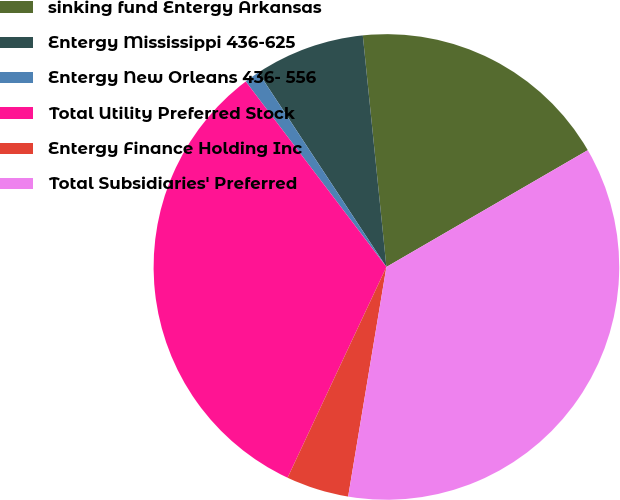Convert chart. <chart><loc_0><loc_0><loc_500><loc_500><pie_chart><fcel>sinking fund Entergy Arkansas<fcel>Entergy Mississippi 436-625<fcel>Entergy New Orleans 436- 556<fcel>Total Utility Preferred Stock<fcel>Entergy Finance Holding Inc<fcel>Total Subsidiaries' Preferred<nl><fcel>18.25%<fcel>7.65%<fcel>1.06%<fcel>32.69%<fcel>4.35%<fcel>35.99%<nl></chart> 